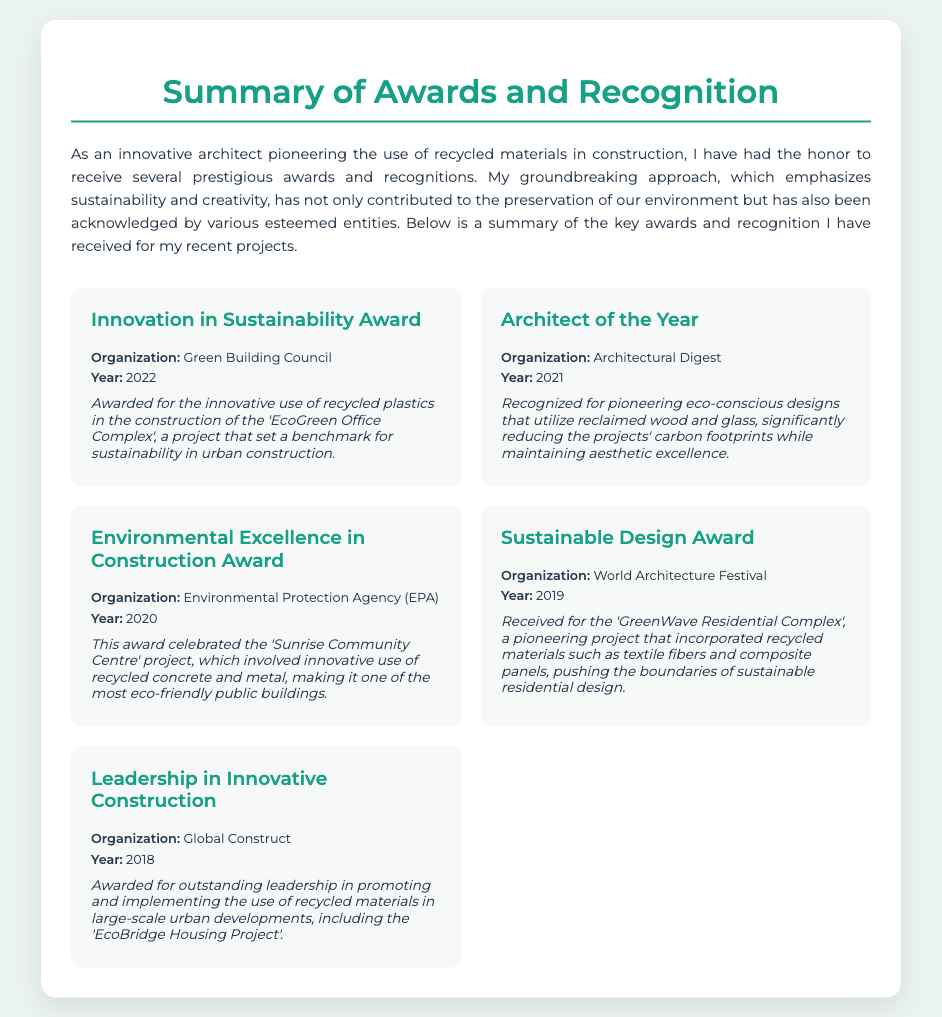What is the title of the document? The title of the document is presented prominently at the top of the envelope, summarizing the content.
Answer: Summary of Awards and Recognition Who awarded the Innovation in Sustainability Award? The organization that awarded this title is mentioned alongside the award name.
Answer: Green Building Council In which year did the Architect of the Year award take place? The year is specified directly after the award name and organization in the document.
Answer: 2021 What project was celebrated by the Environmental Excellence in Construction Award? The document mentions the specific project that was recognized for its eco-friendly contributions.
Answer: Sunrise Community Centre Which award did the document mention for the year 2019? The award type is listed with the corresponding year and related information.
Answer: Sustainable Design Award How many awards are mentioned in total? The total number can be counted from the list of awards presented in the document.
Answer: Five What materials were emphasized in the GreenWave Residential Complex project? The specific types of materials used in the project are noted in the description of the award.
Answer: Recycled materials What is the main theme of the awards and recognition described? The document focuses on the overall theme and approach of the architect's work recognized by several awards.
Answer: Innovative use of recycled materials What does the Leadership in Innovative Construction award recognize? The details in the description highlight the focus of the award and its implications.
Answer: Outstanding leadership in promoting recycled materials 